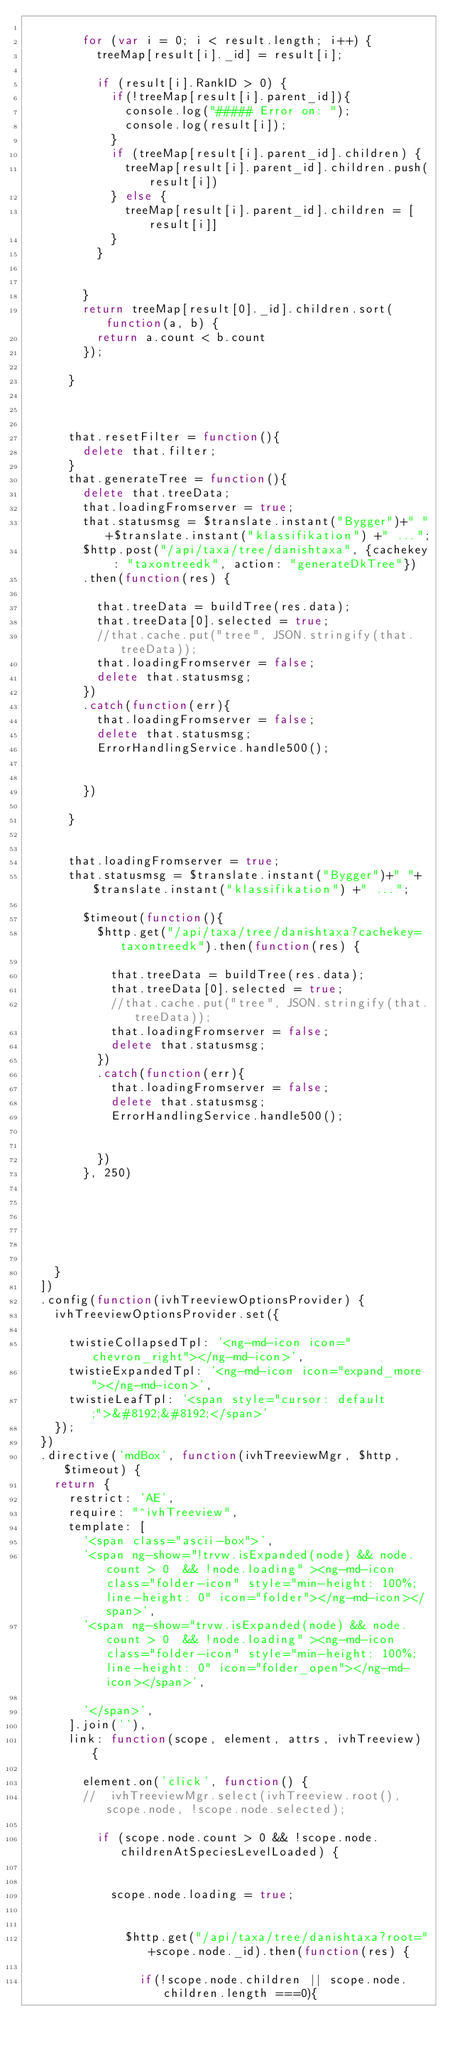Convert code to text. <code><loc_0><loc_0><loc_500><loc_500><_JavaScript_>				
				for (var i = 0; i < result.length; i++) {
					treeMap[result[i]._id] = result[i];

					if (result[i].RankID > 0) {
						if(!treeMap[result[i].parent_id]){
							console.log("##### Error on: ");
							console.log(result[i]);
						}
						if (treeMap[result[i].parent_id].children) {
							treeMap[result[i].parent_id].children.push(result[i])
						} else {
							treeMap[result[i].parent_id].children = [result[i]]
						}
					}
					
					
				}
				return treeMap[result[0]._id].children.sort(function(a, b) {
					return a.count < b.count
				});
				
			}
		

			
			that.resetFilter = function(){
				delete that.filter;
			}
			that.generateTree = function(){
				delete that.treeData;
				that.loadingFromserver = true;
				that.statusmsg = $translate.instant("Bygger")+" "+$translate.instant("klassifikation") +" ...";
				$http.post("/api/taxa/tree/danishtaxa", {cachekey : "taxontreedk", action: "generateDkTree"})
				.then(function(res) {
					
					that.treeData = buildTree(res.data);
					that.treeData[0].selected = true;
					//that.cache.put("tree", JSON.stringify(that.treeData));
					that.loadingFromserver = false;
					delete that.statusmsg;
				})
				.catch(function(err){
					that.loadingFromserver = false;
					delete that.statusmsg;
					ErrorHandlingService.handle500();
					
					
				})
				
			}

			
			that.loadingFromserver = true;
			that.statusmsg = $translate.instant("Bygger")+" "+$translate.instant("klassifikation") +" ...";
				
				$timeout(function(){
					$http.get("/api/taxa/tree/danishtaxa?cachekey=taxontreedk").then(function(res) {
						
						that.treeData = buildTree(res.data);
						that.treeData[0].selected = true;
						//that.cache.put("tree", JSON.stringify(that.treeData));
						that.loadingFromserver = false;
						delete that.statusmsg;
					})
					.catch(function(err){
						that.loadingFromserver = false;
						delete that.statusmsg;
						ErrorHandlingService.handle500();
					
					
					})
				}, 250)

				




		}
	])
	.config(function(ivhTreeviewOptionsProvider) {
		ivhTreeviewOptionsProvider.set({

			twistieCollapsedTpl: '<ng-md-icon icon="chevron_right"></ng-md-icon>',
			twistieExpandedTpl: '<ng-md-icon icon="expand_more"></ng-md-icon>',
			twistieLeafTpl: '<span style="cursor: default;">&#8192;&#8192;</span>'
		});
	})
	.directive('mdBox', function(ivhTreeviewMgr, $http, $timeout) {
		return {
			restrict: 'AE',
			require: "^ivhTreeview",
			template: [
				'<span class="ascii-box">',
				'<span ng-show="!trvw.isExpanded(node) && node.count > 0  && !node.loading" ><ng-md-icon class="folder-icon" style="min-height: 100%; line-height: 0" icon="folder"></ng-md-icon></span>',
				'<span ng-show="trvw.isExpanded(node) && node.count > 0  && !node.loading" ><ng-md-icon class="folder-icon" style="min-height: 100%; line-height: 0" icon="folder_open"></ng-md-icon></span>',

				'</span>',
			].join(''),
			link: function(scope, element, attrs, ivhTreeview) {

				element.on('click', function() {
				//	ivhTreeviewMgr.select(ivhTreeview.root(), scope.node, !scope.node.selected);

					if (scope.node.count > 0 && !scope.node.childrenAtSpeciesLevelLoaded) {


						scope.node.loading = true;


							$http.get("/api/taxa/tree/danishtaxa?root="+scope.node._id).then(function(res) {
								
								if(!scope.node.children || scope.node.children.length ===0){</code> 